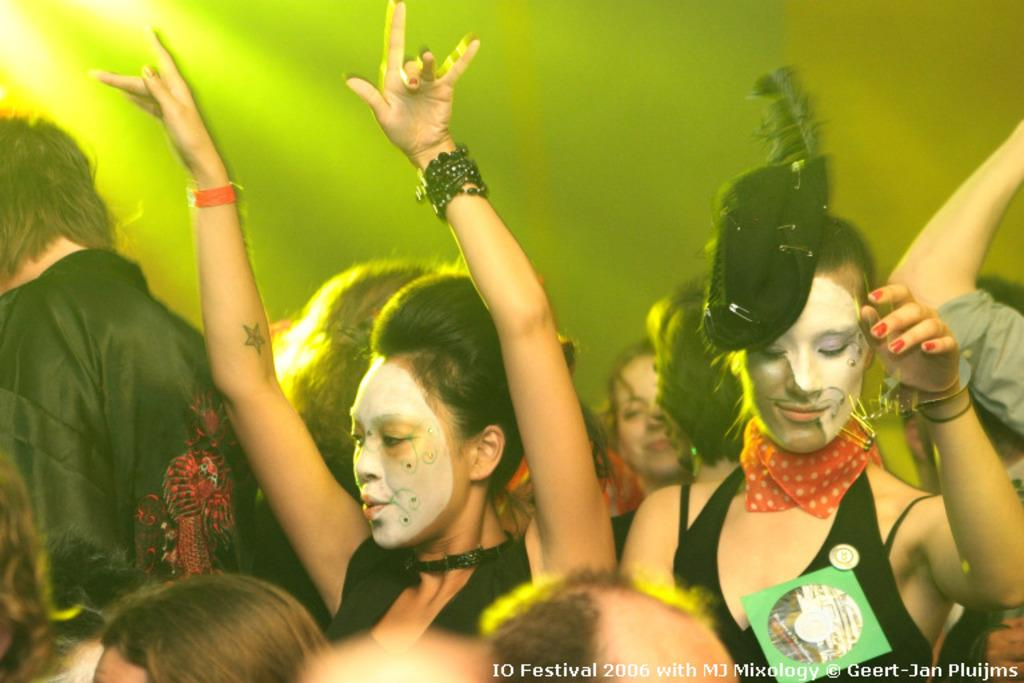How many individuals are present in the image? There are many people in the image. Can you describe the describe the attire of one of the individuals? A lady is wearing a hat in the image. What is the primary source of illumination in the image? There is a light focus in the image. Where is the text located in the image? The text is at the bottom left side of the image. What type of fang can be seen in the image? There are no fangs present in the image. What mode of transportation is used for the voyage depicted in the image? There is no voyage depicted in the image, so it is not possible to determine the mode of transportation. 